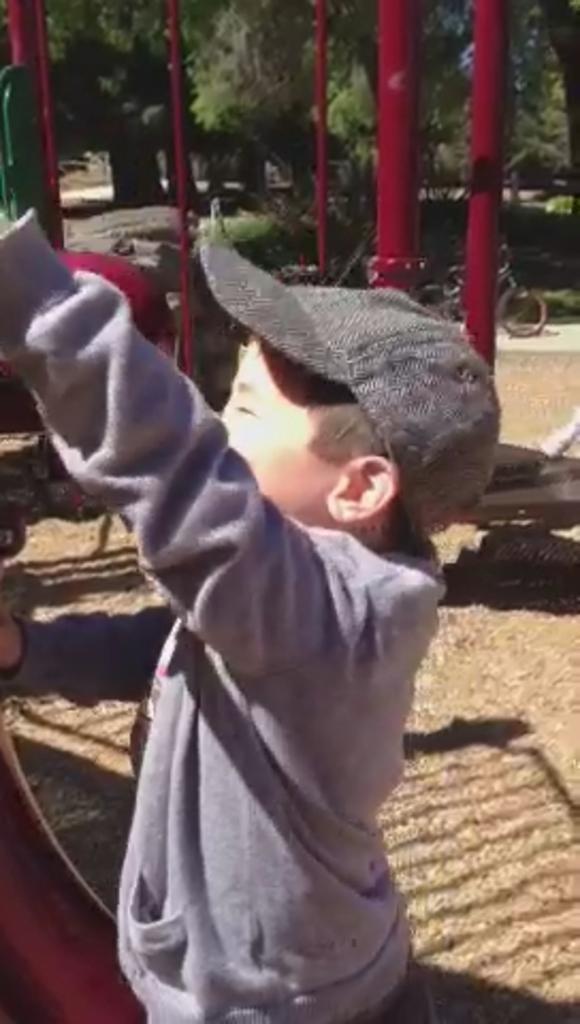Please provide a concise description of this image. In this image there are trees towards the top of the image, there is a bicycle, there are metal rods towards the top of the image, there is ground towards the bottom of the image, there is an object towards the left of the image, there is a boy standing towards the bottom of the image, he is wearing a cap. 